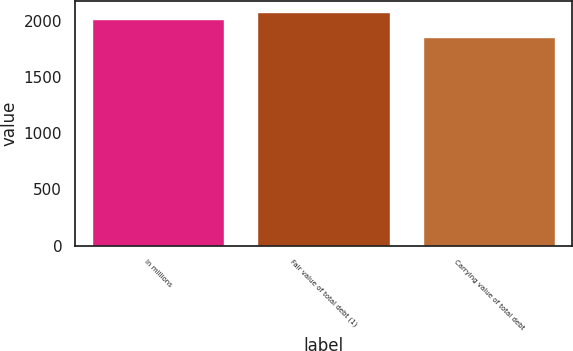Convert chart. <chart><loc_0><loc_0><loc_500><loc_500><bar_chart><fcel>In millions<fcel>Fair value of total debt (1)<fcel>Carrying value of total debt<nl><fcel>2016<fcel>2077<fcel>1856<nl></chart> 